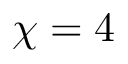Convert formula to latex. <formula><loc_0><loc_0><loc_500><loc_500>\chi = 4</formula> 